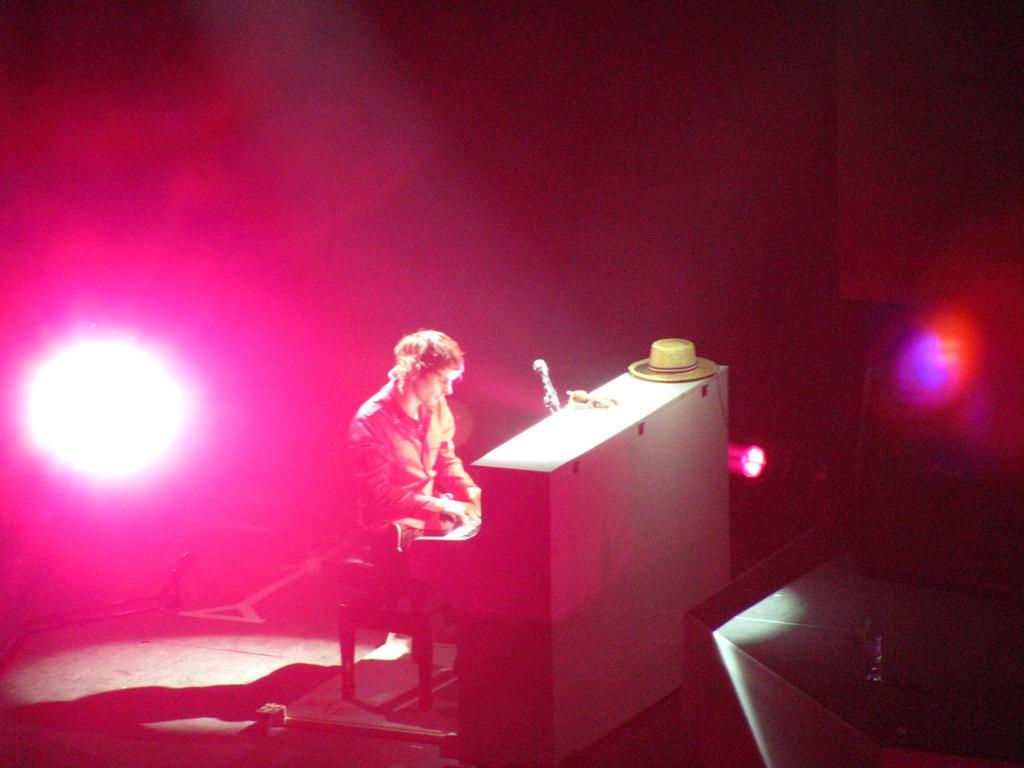Can you describe this image briefly? In this image I can see a man sitting on table , in front of the man I can see a table , on the table I can see a cap and at the top I can see light focus and background color is pink. 